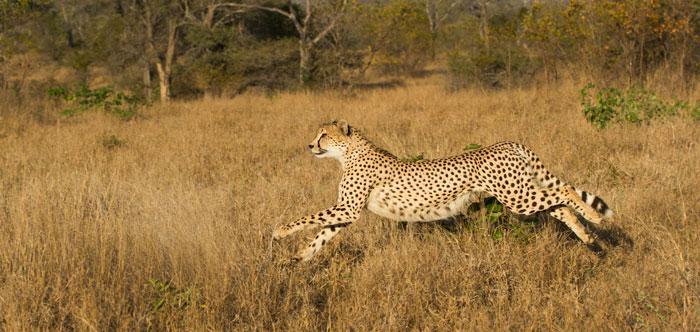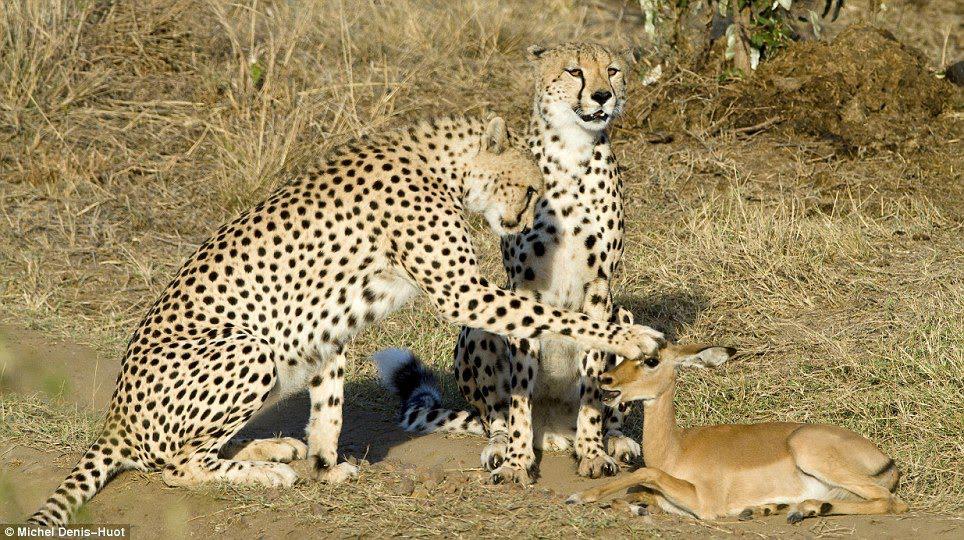The first image is the image on the left, the second image is the image on the right. For the images shown, is this caption "In one of the images there is a single leopard running." true? Answer yes or no. Yes. The first image is the image on the left, the second image is the image on the right. Assess this claim about the two images: "There are three total cheetahs.". Correct or not? Answer yes or no. Yes. 